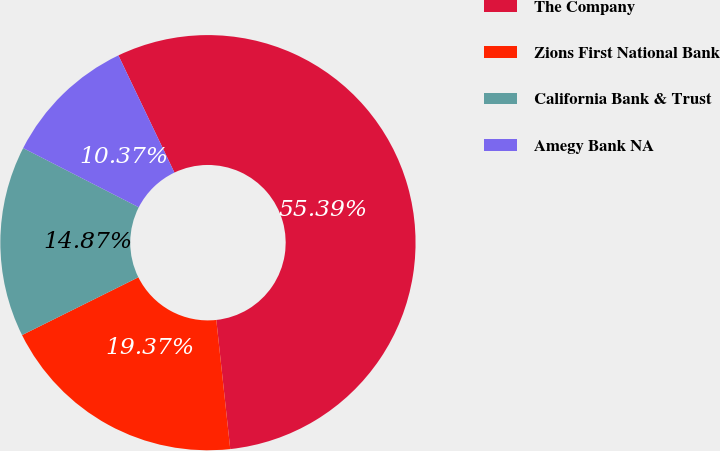Convert chart. <chart><loc_0><loc_0><loc_500><loc_500><pie_chart><fcel>The Company<fcel>Zions First National Bank<fcel>California Bank & Trust<fcel>Amegy Bank NA<nl><fcel>55.38%<fcel>19.37%<fcel>14.87%<fcel>10.37%<nl></chart> 